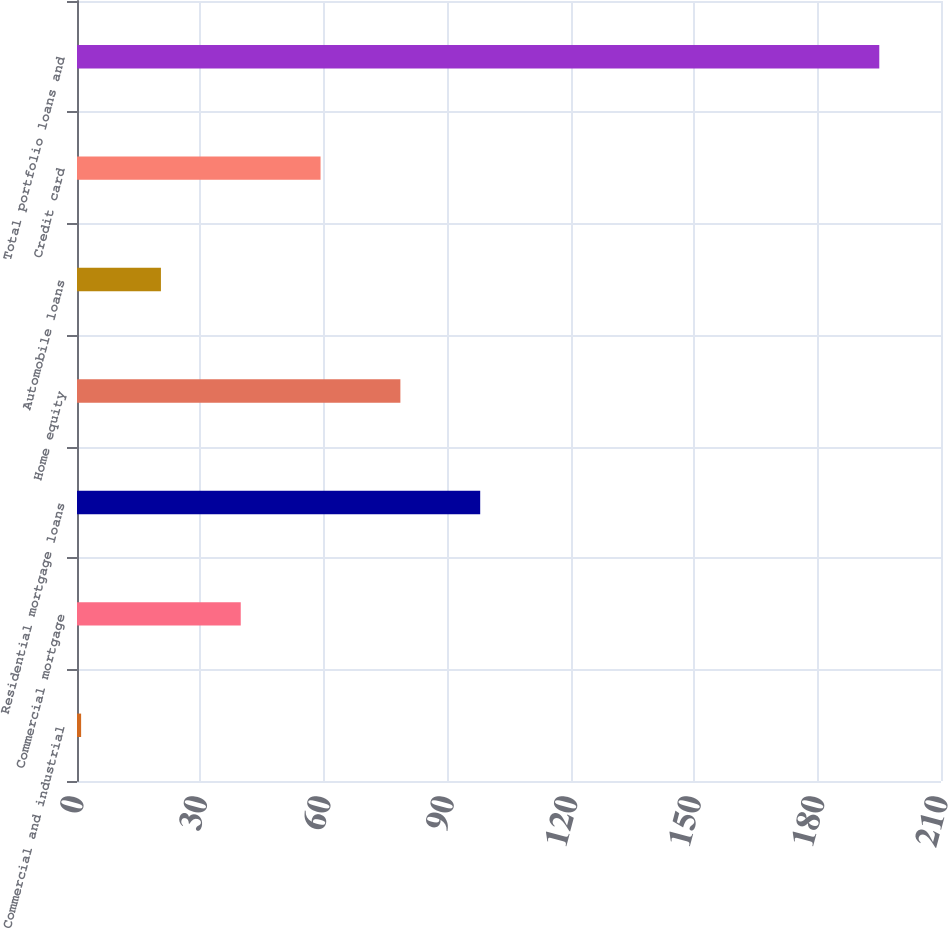<chart> <loc_0><loc_0><loc_500><loc_500><bar_chart><fcel>Commercial and industrial<fcel>Commercial mortgage<fcel>Residential mortgage loans<fcel>Home equity<fcel>Automobile loans<fcel>Credit card<fcel>Total portfolio loans and<nl><fcel>1<fcel>39.8<fcel>98<fcel>78.6<fcel>20.4<fcel>59.2<fcel>195<nl></chart> 